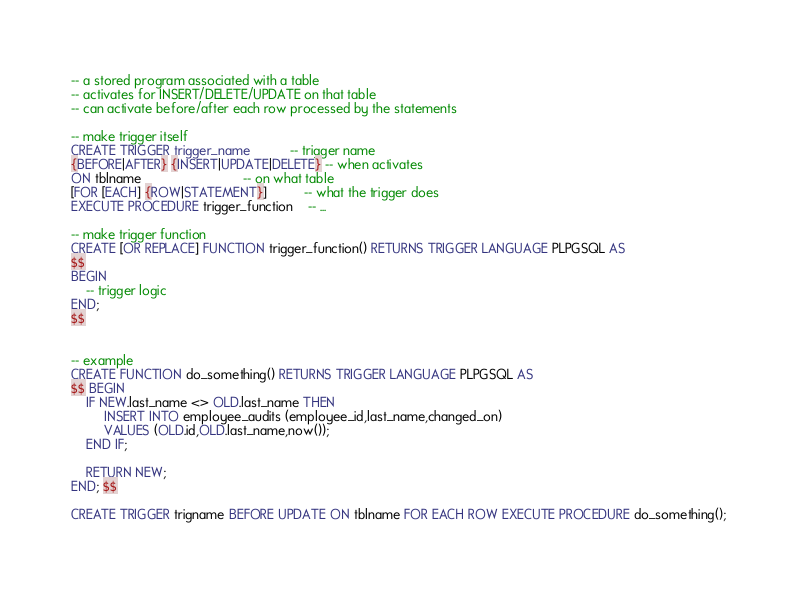Convert code to text. <code><loc_0><loc_0><loc_500><loc_500><_SQL_>-- a stored program associated with a table
-- activates for INSERT/DELETE/UPDATE on that table
-- can activate before/after each row processed by the statements

-- make trigger itself
CREATE TRIGGER trigger_name           -- trigger name
{BEFORE|AFTER} {INSERT|UPDATE|DELETE} -- when activates
ON tblname                            -- on what table
[FOR [EACH] {ROW|STATEMENT}]          -- what the trigger does
EXECUTE PROCEDURE trigger_function    -- ...

-- make trigger function
CREATE [OR REPLACE] FUNCTION trigger_function() RETURNS TRIGGER LANGUAGE PLPGSQL AS
$$
BEGIN
	-- trigger logic
END;
$$


-- example
CREATE FUNCTION do_something() RETURNS TRIGGER LANGUAGE PLPGSQL AS
$$ BEGIN
	IF NEW.last_name <> OLD.last_name THEN
		 INSERT INTO employee_audits (employee_id,last_name,changed_on)
		 VALUES (OLD.id,OLD.last_name,now());
	END IF;
	
	RETURN NEW;
END; $$

CREATE TRIGGER trigname BEFORE UPDATE ON tblname FOR EACH ROW EXECUTE PROCEDURE do_something();</code> 